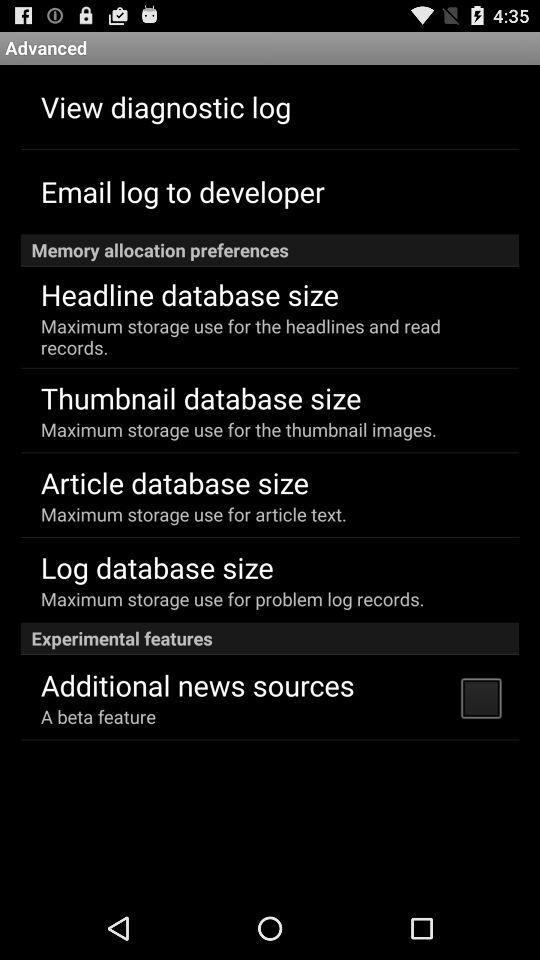What is the status of the "Additional news sources"? The status of the "Additional news sources" is "off". 